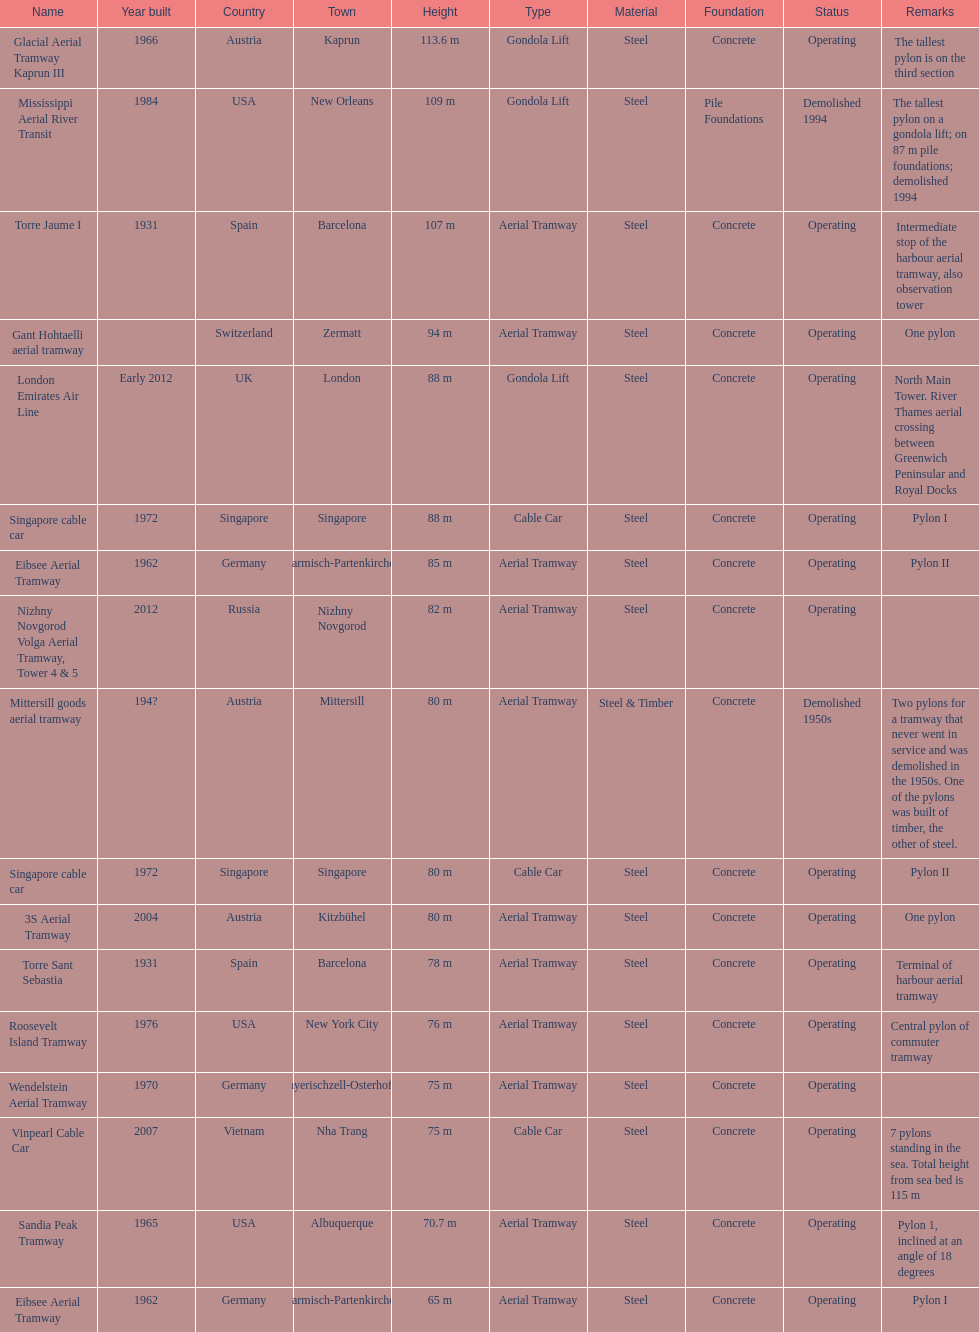What is the total number of tallest pylons in austria? 3. 